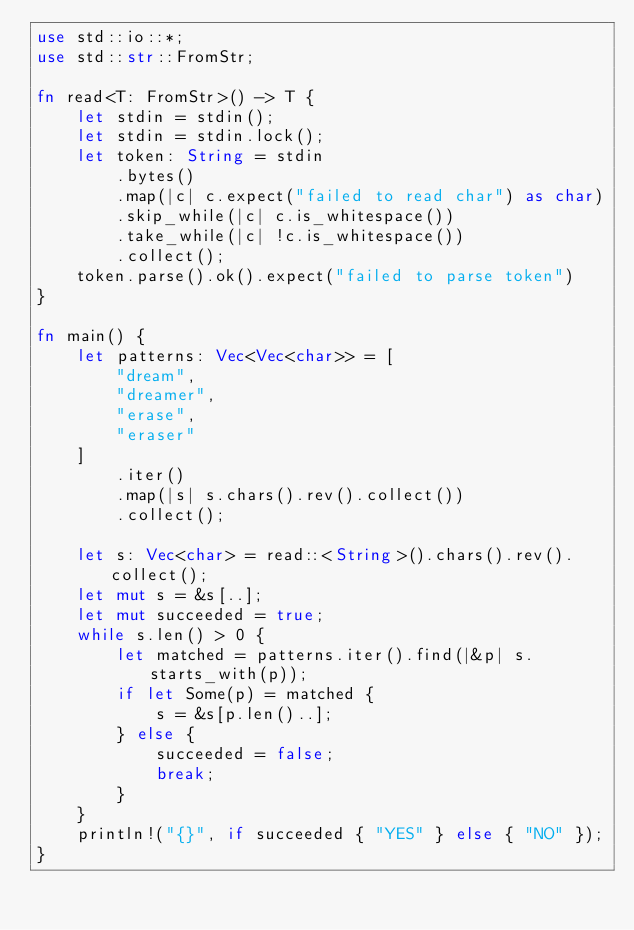Convert code to text. <code><loc_0><loc_0><loc_500><loc_500><_Rust_>use std::io::*;
use std::str::FromStr;

fn read<T: FromStr>() -> T {
    let stdin = stdin();
    let stdin = stdin.lock();
    let token: String = stdin
        .bytes()
        .map(|c| c.expect("failed to read char") as char)
        .skip_while(|c| c.is_whitespace())
        .take_while(|c| !c.is_whitespace())
        .collect();
    token.parse().ok().expect("failed to parse token")
}

fn main() {
    let patterns: Vec<Vec<char>> = [
        "dream",
        "dreamer",
        "erase",
        "eraser"
    ]
        .iter()
        .map(|s| s.chars().rev().collect())
        .collect();

    let s: Vec<char> = read::<String>().chars().rev().collect();
    let mut s = &s[..];
    let mut succeeded = true;
    while s.len() > 0 {
        let matched = patterns.iter().find(|&p| s.starts_with(p));
        if let Some(p) = matched {
            s = &s[p.len()..];
        } else {
            succeeded = false;
            break;
        }
    }
    println!("{}", if succeeded { "YES" } else { "NO" });
}
</code> 